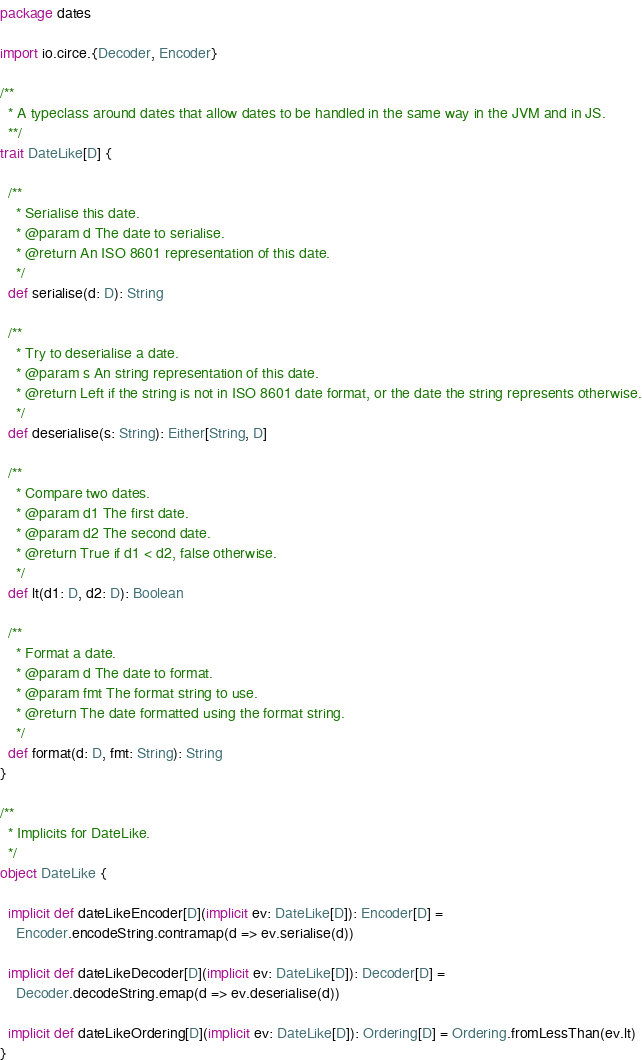Convert code to text. <code><loc_0><loc_0><loc_500><loc_500><_Scala_>package dates

import io.circe.{Decoder, Encoder}

/**
  * A typeclass around dates that allow dates to be handled in the same way in the JVM and in JS.
  **/
trait DateLike[D] {

  /**
    * Serialise this date.
    * @param d The date to serialise.
    * @return An ISO 8601 representation of this date.
    */
  def serialise(d: D): String

  /**
    * Try to deserialise a date.
    * @param s An string representation of this date.
    * @return Left if the string is not in ISO 8601 date format, or the date the string represents otherwise.
    */
  def deserialise(s: String): Either[String, D]

  /**
    * Compare two dates.
    * @param d1 The first date.
    * @param d2 The second date.
    * @return True if d1 < d2, false otherwise.
    */
  def lt(d1: D, d2: D): Boolean

  /**
    * Format a date.
    * @param d The date to format.
    * @param fmt The format string to use.
    * @return The date formatted using the format string.
    */
  def format(d: D, fmt: String): String
}

/**
  * Implicits for DateLike.
  */
object DateLike {

  implicit def dateLikeEncoder[D](implicit ev: DateLike[D]): Encoder[D] =
    Encoder.encodeString.contramap(d => ev.serialise(d))

  implicit def dateLikeDecoder[D](implicit ev: DateLike[D]): Decoder[D] =
    Decoder.decodeString.emap(d => ev.deserialise(d))

  implicit def dateLikeOrdering[D](implicit ev: DateLike[D]): Ordering[D] = Ordering.fromLessThan(ev.lt)
}</code> 